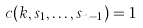Convert formula to latex. <formula><loc_0><loc_0><loc_500><loc_500>c ( k , s _ { 1 } , \dots , s _ { n - 1 } ) = 1</formula> 